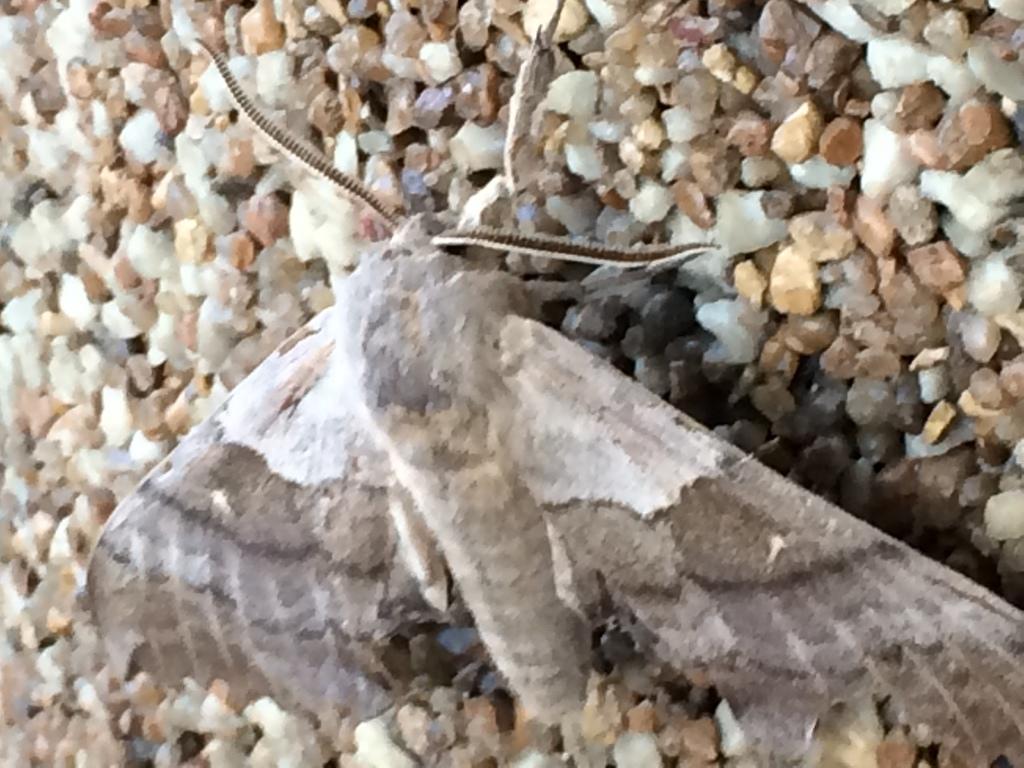Could you give a brief overview of what you see in this image? In this picture I can see in the middle there is an insect and there are stones. 